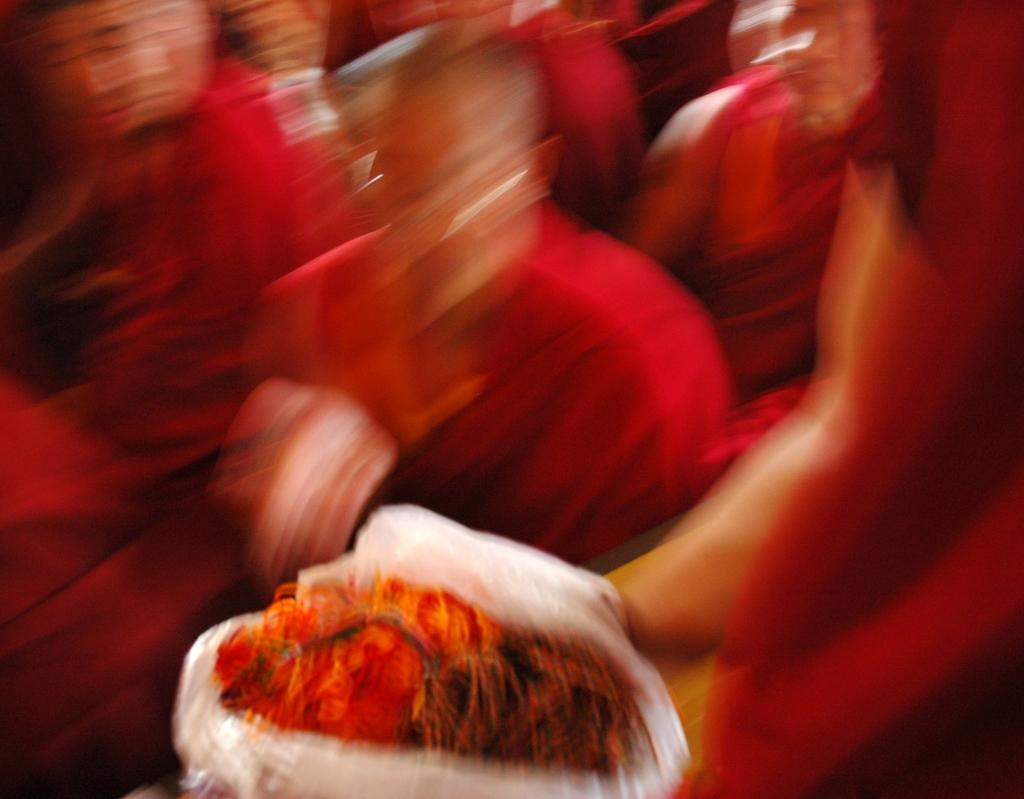What is located at the bottom of the image? There is a cover at the bottom of the image. What can be seen at the top of the image? There are people at the top of the image. How would you describe the clarity of the image? The image is blurry. What type of cub is visible in the image? There is no cub present in the image. How does the throat of the person at the top of the image look? There is no information about the person's throat in the image. 